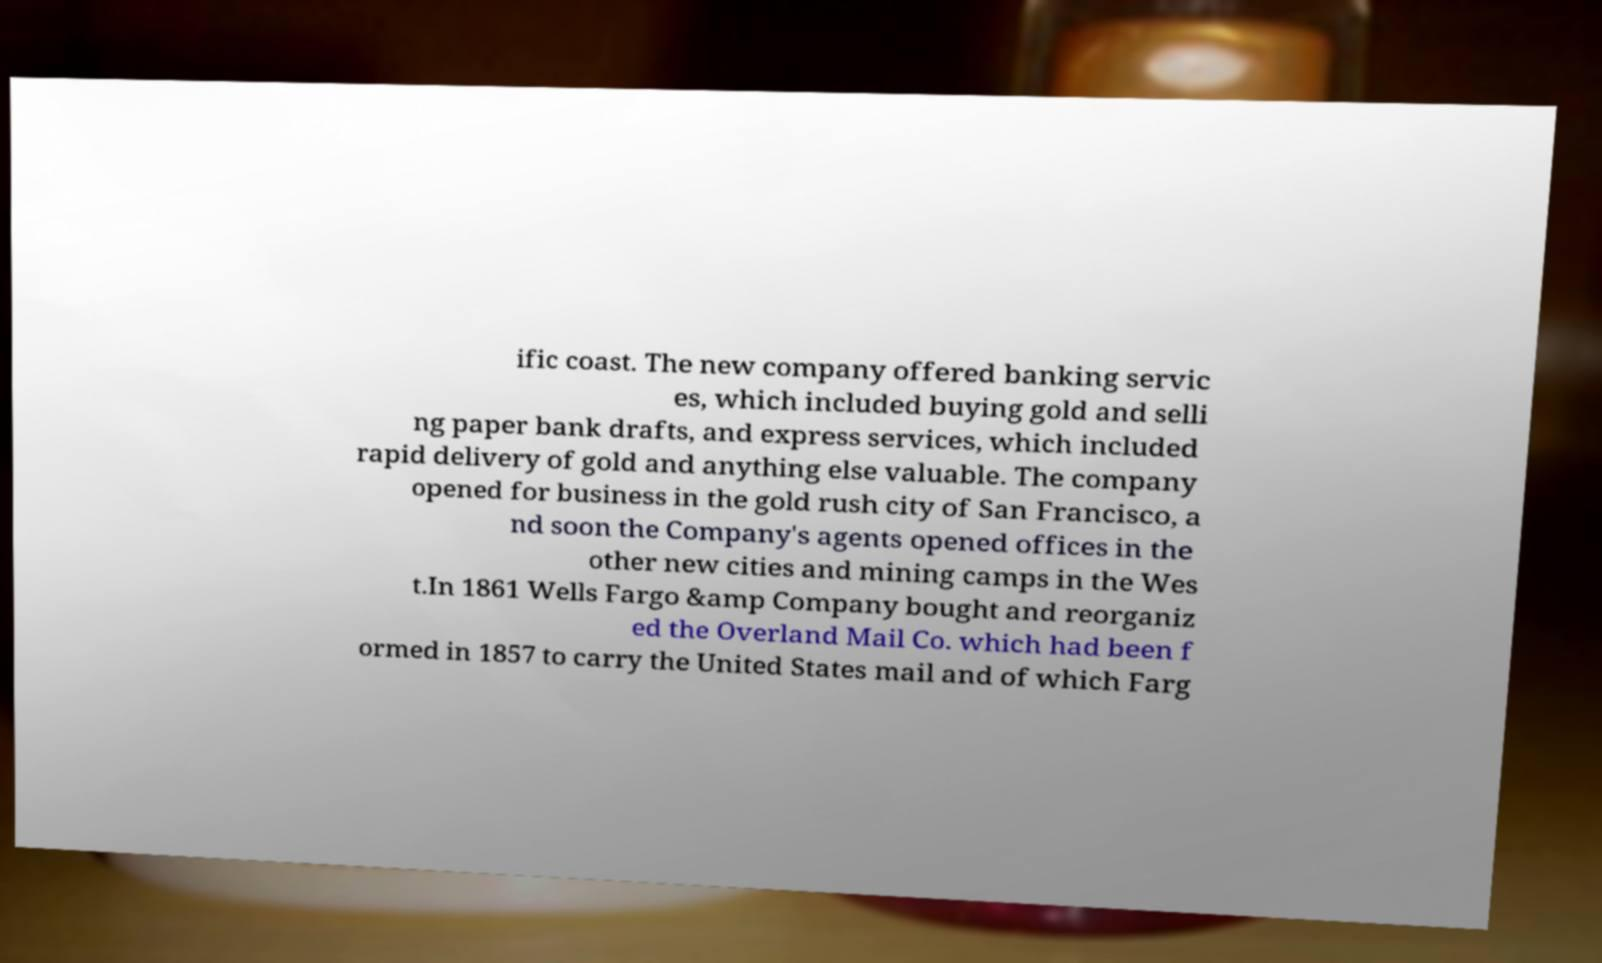For documentation purposes, I need the text within this image transcribed. Could you provide that? ific coast. The new company offered banking servic es, which included buying gold and selli ng paper bank drafts, and express services, which included rapid delivery of gold and anything else valuable. The company opened for business in the gold rush city of San Francisco, a nd soon the Company's agents opened offices in the other new cities and mining camps in the Wes t.In 1861 Wells Fargo &amp Company bought and reorganiz ed the Overland Mail Co. which had been f ormed in 1857 to carry the United States mail and of which Farg 